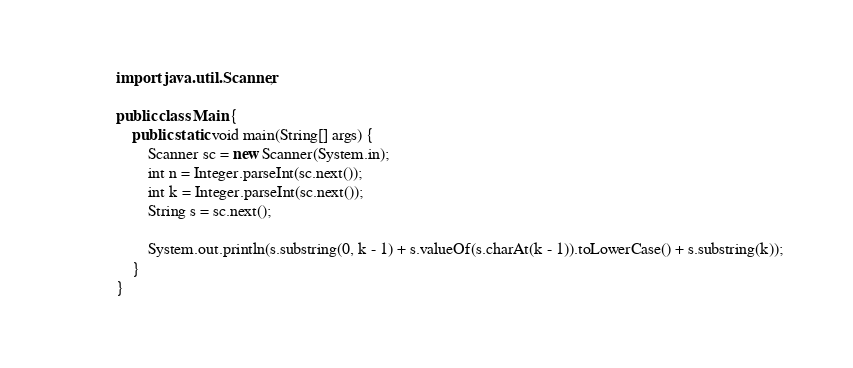<code> <loc_0><loc_0><loc_500><loc_500><_Java_>import java.util.Scanner;

public class Main {
    public static void main(String[] args) {
        Scanner sc = new Scanner(System.in);
        int n = Integer.parseInt(sc.next());
        int k = Integer.parseInt(sc.next());
        String s = sc.next();

        System.out.println(s.substring(0, k - 1) + s.valueOf(s.charAt(k - 1)).toLowerCase() + s.substring(k));
    }
}
</code> 